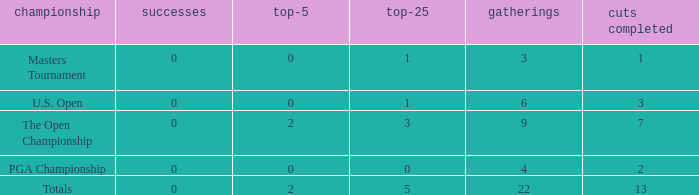What is the total number of wins for events with under 2 top-5s, under 5 top-25s, and more than 4 events played? 1.0. 